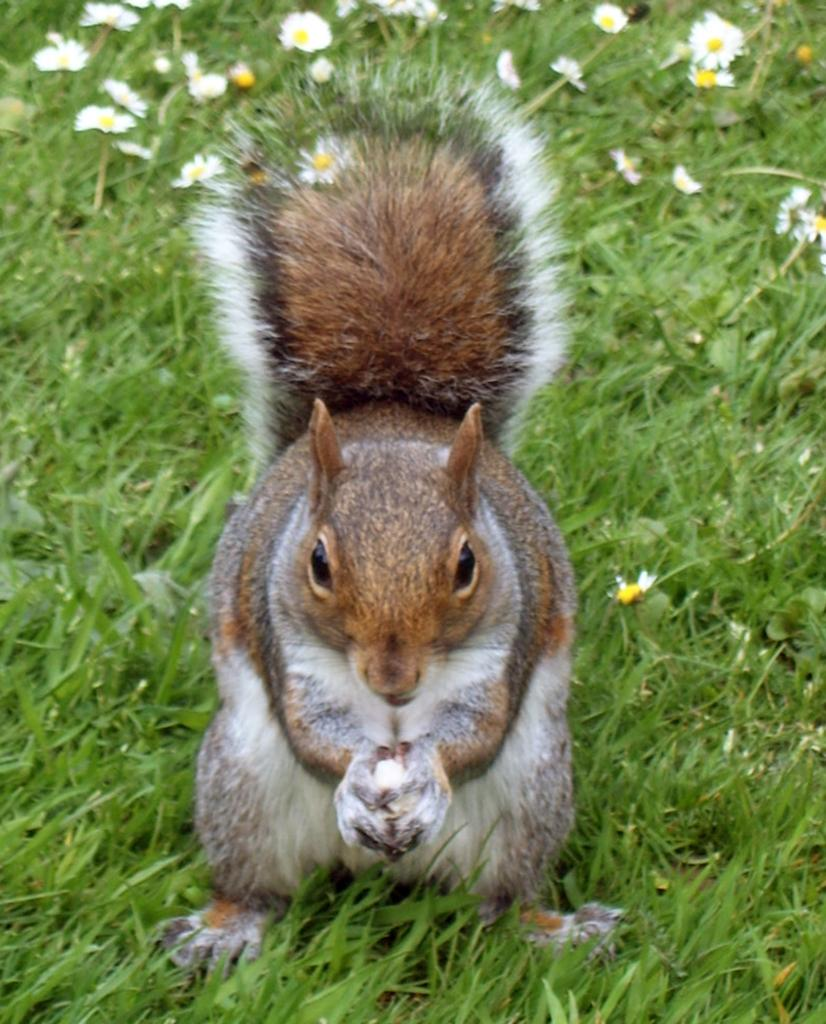What type of animal is in the image? There is a squirrel in the image. What is the squirrel doing in the image? The squirrel is holding something in its hands. What can be seen in the background of the image? There is green grass visible in the image. Are there any plants or flowers in the image? Yes, there are flowers in the image. What type of agreement is being discussed by the bear in the image? There is no bear present in the image, and therefore no discussion of an agreement can be observed. 